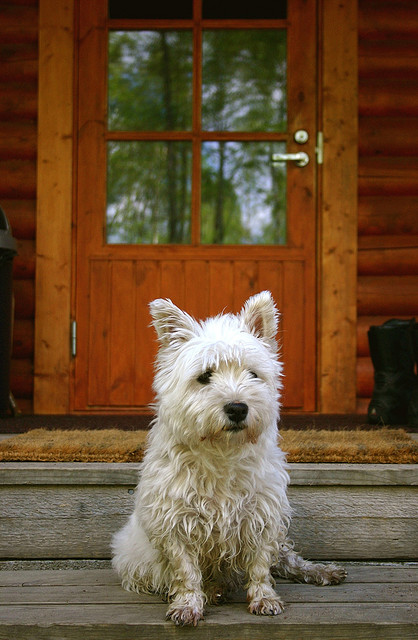What breed of dog is this? This is most likely a West Highland White Terrier, also known as a Westie. These dogs are easily identifiable by their pure white fur, compact size, and vibrant, curious expressions. They are beloved for their friendly demeanor and energetic personality. 